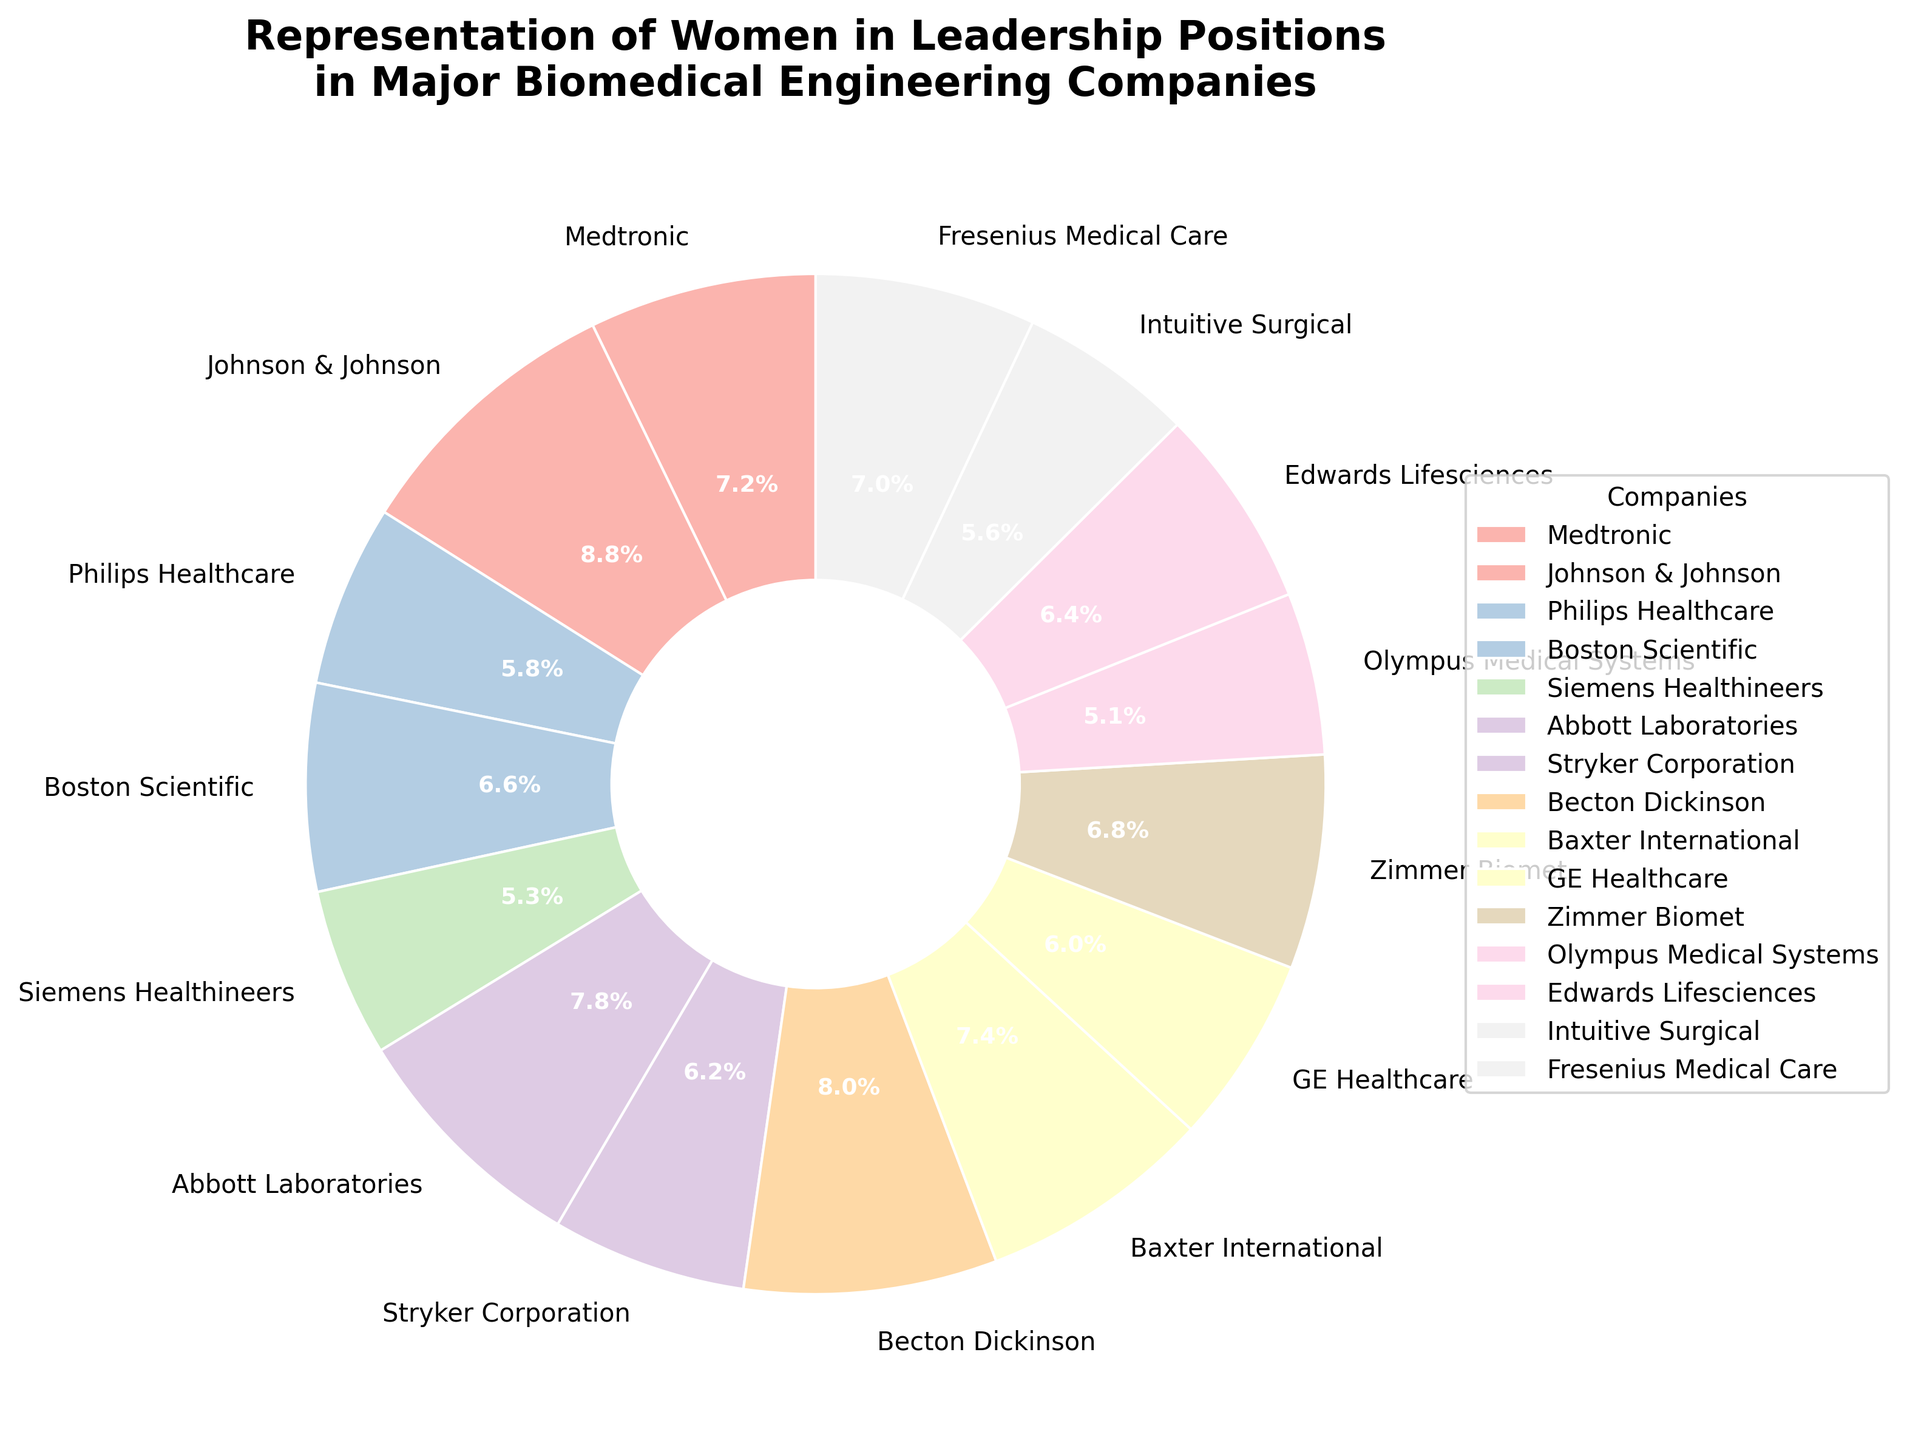What percentage of leadership positions in Medtronic are held by women? The percentage of women in leadership positions at Medtronic can be directly found on the pie chart next to the label for Medtronic.
Answer: 35% Which company has the highest percentage of women in leadership positions and what is that percentage? By examining the pie chart, the company with the highest percentage can be identified, which is labelled with its percentage.
Answer: Johnson & Johnson, 43% Compare the percentage of women in leadership positions between Medtronic and Philips Healthcare. Which company has a higher percentage and by how much? Locate Medtronic and Philips Healthcare on the pie chart and note their percentages. The difference between these two percentages will give the answer.
Answer: Medtronic has 35% and Philips Healthcare has 28%, so Medtronic has a higher percentage by 7% What is the total percentage of women in leadership for Siemens Healthineers, Olympus Medical Systems, and Intuitive Surgical combined? Find and sum the percentages for Siemens Healthineers, Olympus Medical Systems, and Intuitive Surgical.
Answer: 26% + 25% + 27% = 78% Is the percentage of women in leadership at Abbott Laboratories greater than that at GE Healthcare? Compare the percentage labels on the pie chart for Abbott Laboratories and GE Healthcare.
Answer: Yes, Abbott Laboratories (38%) is greater than GE Healthcare (29%) Are there more companies with less than 30% or more than 30% of women in leadership positions? Count the number of companies with less than 30% and those with more than 30% based on the pie chart labels.
Answer: More than 30% What's the difference in the percentage of women in leadership between the company with the highest and the company with the lowest representation? Identify the company with the highest percentage (Johnson & Johnson, 43%) and the lowest (Olympus Medical Systems, 25%) and calculate the difference.
Answer: 43% - 25% = 18% Which companies have a representation of women in leadership positions close to the average percentage of all listed companies? First, calculate the average percentage: (35 + 43 + 28 + 32 + 26 + 38 + 30 + 39 + 36 + 29 + 33 + 25 + 31 + 27 + 34) / 15 = 32.67%. Then, identify the companies with percentages around this average.
Answer: Boston Scientific (32%), Stryker Corporation (30%), Baxter International (36%), Zimmer Biomet (33%) Which company has the smallest representation of women in leadership positions and what is the exact percentage? Find the label with the smallest percentage on the pie chart.
Answer: Olympus Medical Systems, 25% If Medtronic increased its percentage of women in leadership by 5%, what would the new percentage be? Would this change make Medtronic the company with the highest percentage of women in leadership? Add 5% to the current percentage for Medtronic (35% + 5% = 40%). Compare this to the highest percentage currently (Johnson & Johnson, 43%).
Answer: New percentage would be 40%. No, it would not make it the highest 